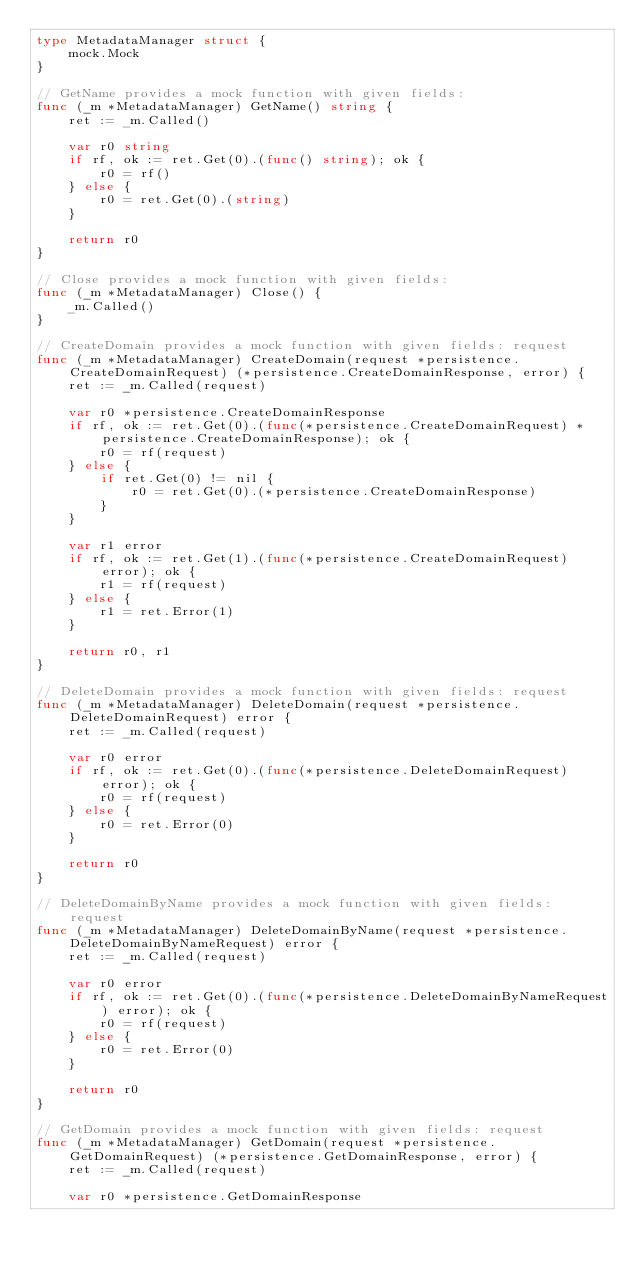<code> <loc_0><loc_0><loc_500><loc_500><_Go_>type MetadataManager struct {
	mock.Mock
}

// GetName provides a mock function with given fields:
func (_m *MetadataManager) GetName() string {
	ret := _m.Called()

	var r0 string
	if rf, ok := ret.Get(0).(func() string); ok {
		r0 = rf()
	} else {
		r0 = ret.Get(0).(string)
	}

	return r0
}

// Close provides a mock function with given fields:
func (_m *MetadataManager) Close() {
	_m.Called()
}

// CreateDomain provides a mock function with given fields: request
func (_m *MetadataManager) CreateDomain(request *persistence.CreateDomainRequest) (*persistence.CreateDomainResponse, error) {
	ret := _m.Called(request)

	var r0 *persistence.CreateDomainResponse
	if rf, ok := ret.Get(0).(func(*persistence.CreateDomainRequest) *persistence.CreateDomainResponse); ok {
		r0 = rf(request)
	} else {
		if ret.Get(0) != nil {
			r0 = ret.Get(0).(*persistence.CreateDomainResponse)
		}
	}

	var r1 error
	if rf, ok := ret.Get(1).(func(*persistence.CreateDomainRequest) error); ok {
		r1 = rf(request)
	} else {
		r1 = ret.Error(1)
	}

	return r0, r1
}

// DeleteDomain provides a mock function with given fields: request
func (_m *MetadataManager) DeleteDomain(request *persistence.DeleteDomainRequest) error {
	ret := _m.Called(request)

	var r0 error
	if rf, ok := ret.Get(0).(func(*persistence.DeleteDomainRequest) error); ok {
		r0 = rf(request)
	} else {
		r0 = ret.Error(0)
	}

	return r0
}

// DeleteDomainByName provides a mock function with given fields: request
func (_m *MetadataManager) DeleteDomainByName(request *persistence.DeleteDomainByNameRequest) error {
	ret := _m.Called(request)

	var r0 error
	if rf, ok := ret.Get(0).(func(*persistence.DeleteDomainByNameRequest) error); ok {
		r0 = rf(request)
	} else {
		r0 = ret.Error(0)
	}

	return r0
}

// GetDomain provides a mock function with given fields: request
func (_m *MetadataManager) GetDomain(request *persistence.GetDomainRequest) (*persistence.GetDomainResponse, error) {
	ret := _m.Called(request)

	var r0 *persistence.GetDomainResponse</code> 